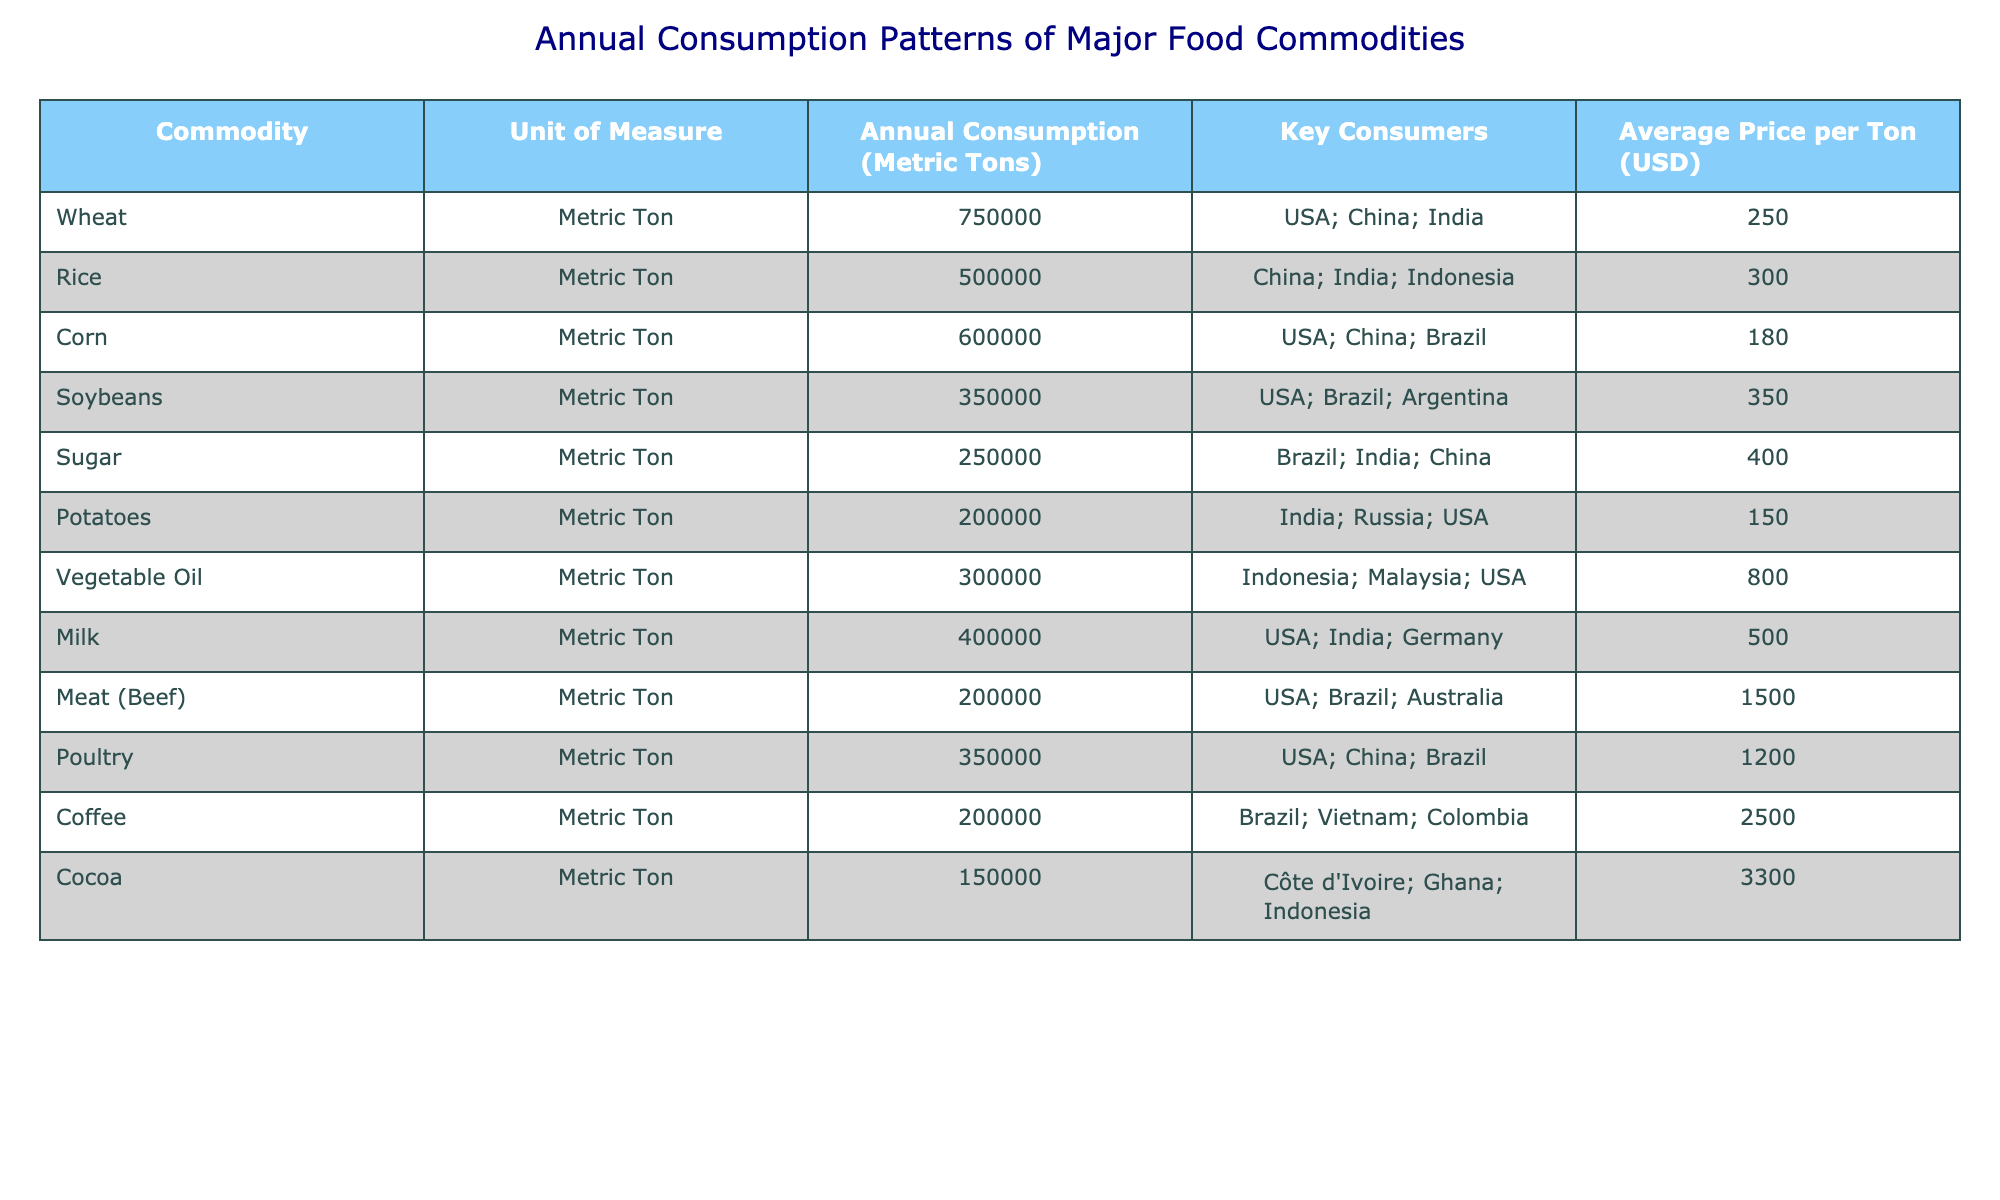What is the annual consumption of Wheat? The table shows that the annual consumption of Wheat is listed directly under the "Annual Consumption (Metric Tons)" column corresponding to Wheat, which is 750,000 metric tons.
Answer: 750,000 metric tons Which commodity has the highest average price per ton? By comparing the values in the "Average Price per Ton (USD)" column, the highest value is seen next to Cocoa, which is 3,300 USD per ton.
Answer: Cocoa How many metric tons of Rice are consumed annually by the top three consumers? The total consumption of Rice from the "Annual Consumption (Metric Tons)" column is 500,000 metric tons. Since this is a single value for Rice, it encompasses all the key consumers. Therefore, it directly answers the question.
Answer: 500,000 metric tons Is the average price of Corn higher than that of Sugar? The average price of Corn is 180 USD per ton, and the average price of Sugar is 400 USD per ton. Since 180 is less than 400, the statement is false.
Answer: No What is the total consumption of Meat (Beef) and Poultry combined? To find the total, we add the annual consumption of Meat (Beef) which is 200,000 metric tons to Poultry which is 350,000 metric tons. The sum is 200,000 + 350,000 = 550,000 metric tons.
Answer: 550,000 metric tons Which countries are key consumers for Soybeans? The "Key Consumers" column next to Soybeans lists USA, Brazil, and Argentina. These are the countries identified as key consumers for this commodity.
Answer: USA, Brazil, Argentina What is the average annual consumption of the listed commodities? First, we sum the total consumption of all listed commodities: 750,000 (Wheat) + 500,000 (Rice) + 600,000 (Corn) + 350,000 (Soybeans) + 250,000 (Sugar) + 200,000 (Potatoes) + 300,000 (Vegetable Oil) + 400,000 (Milk) + 200,000 (Meat) + 350,000 (Poultry) + 200,000 (Coffee) + 150,000 (Cocoa) = 3,500,000 metric tons. Then, we divide this by the number of commodities, which is 12. Thus, the average is 3,500,000 / 12 = 291,666.67 metric tons.
Answer: 291,666.67 metric tons Which food commodity has the lowest annual consumption? By reviewing the "Annual Consumption (Metric Tons)" values, Cocoa has the lowest value at 150,000 metric tons.
Answer: Cocoa How many more metric tons of Vegetable Oil are consumed than Milk? The annual consumption of Vegetable Oil is 300,000 metric tons and Milk is 400,000 metric tons. To find the difference, we subtract: 300,000 - 400,000 = -100,000. This indicates there is less Vegetable Oil consumed than Milk.
Answer: -100,000 metric tons 